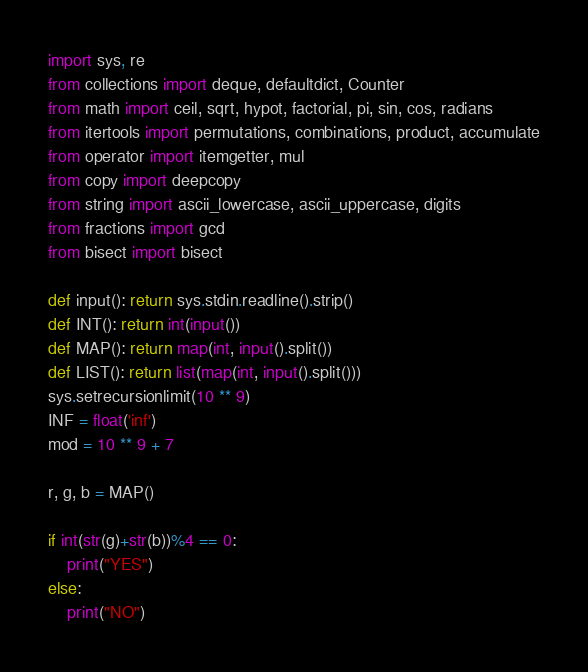Convert code to text. <code><loc_0><loc_0><loc_500><loc_500><_Python_>import sys, re
from collections import deque, defaultdict, Counter
from math import ceil, sqrt, hypot, factorial, pi, sin, cos, radians
from itertools import permutations, combinations, product, accumulate
from operator import itemgetter, mul
from copy import deepcopy
from string import ascii_lowercase, ascii_uppercase, digits
from fractions import gcd
from bisect import bisect

def input(): return sys.stdin.readline().strip()
def INT(): return int(input())
def MAP(): return map(int, input().split())
def LIST(): return list(map(int, input().split()))
sys.setrecursionlimit(10 ** 9)
INF = float('inf')
mod = 10 ** 9 + 7

r, g, b = MAP()

if int(str(g)+str(b))%4 == 0:
	print("YES")
else:
	print("NO")
</code> 